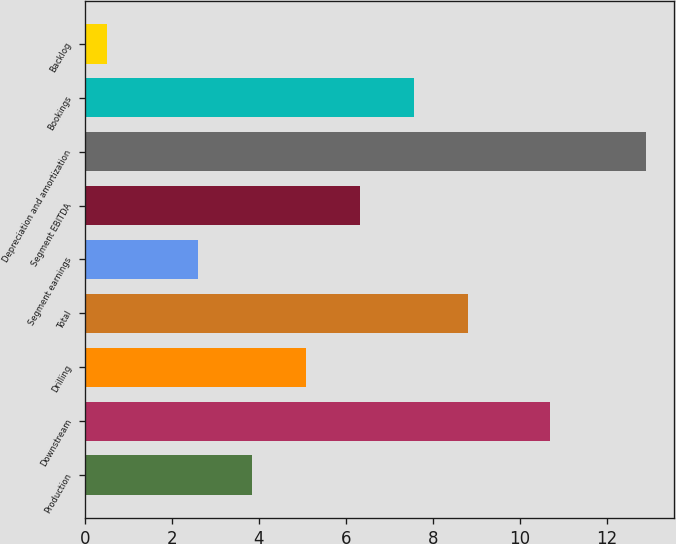<chart> <loc_0><loc_0><loc_500><loc_500><bar_chart><fcel>Production<fcel>Downstream<fcel>Drilling<fcel>Total<fcel>Segment earnings<fcel>Segment EBITDA<fcel>Depreciation and amortization<fcel>Bookings<fcel>Backlog<nl><fcel>3.84<fcel>10.7<fcel>5.08<fcel>8.8<fcel>2.6<fcel>6.32<fcel>12.9<fcel>7.56<fcel>0.5<nl></chart> 